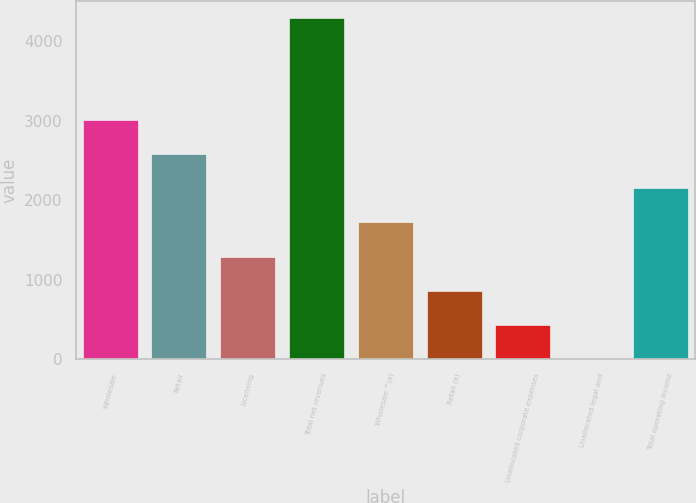Convert chart. <chart><loc_0><loc_0><loc_500><loc_500><bar_chart><fcel>Wholesale<fcel>Retail<fcel>Licensing<fcel>Total net revenues<fcel>Wholesale ^(a)<fcel>Retail (a)<fcel>Unallocated corporate expenses<fcel>Unallocated legal and<fcel>Total operating income<nl><fcel>3009.06<fcel>2580.28<fcel>1293.94<fcel>4295.4<fcel>1722.72<fcel>865.16<fcel>436.38<fcel>7.6<fcel>2151.5<nl></chart> 